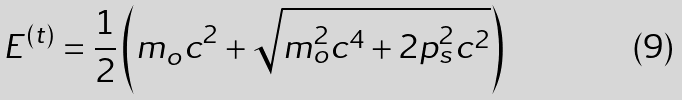Convert formula to latex. <formula><loc_0><loc_0><loc_500><loc_500>E ^ { ( t ) } = \frac { 1 } { 2 } \left ( m _ { o } c ^ { 2 } + \sqrt { m _ { o } ^ { 2 } c ^ { 4 } + 2 p _ { s } ^ { 2 } c ^ { 2 } } \right )</formula> 